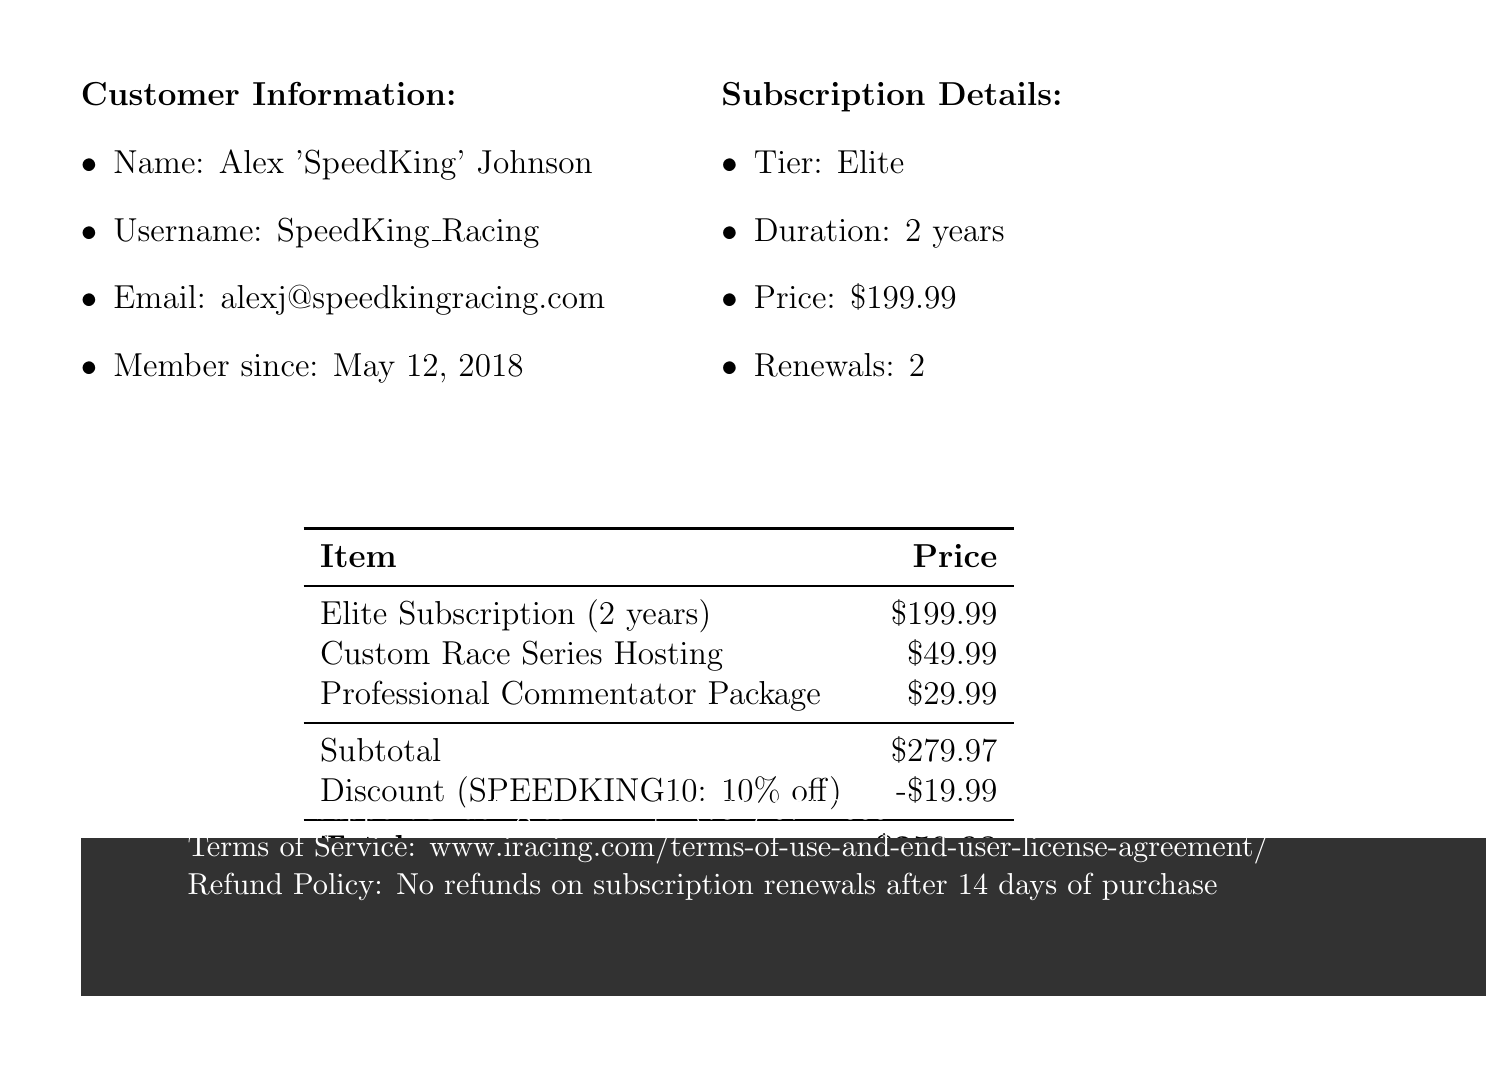What is the company name? The company name is mentioned at the top of the receipt.
Answer: iRacing.com Motorsport Simulations, LLC What is the price of the Elite subscription? The price for the Elite subscription is listed in the subscription details section of the document.
Answer: $199.99 Who is the current subscriber? The subscriber's name is included in the customer information section of the document.
Answer: Alex 'SpeedKing' Johnson How many renewals has the customer had? The number of renewals is detailed in the subscription history section.
Answer: 2 What discount code is mentioned in the document? The promotional offer section provides the discount code.
Answer: SPEEDKING10 What is the total amount after discount? The total amount is calculated in the summary table after applying the discount.
Answer: $259.98 What type of payment methods are accepted? The available payment methods are listed in a specific section of the document.
Answer: Credit Card, PayPal, Apple Pay, Google Pay What additional service costs $29.99? The additional services section provides the cost for each service.
Answer: Professional Commentator Package What is the refund policy on subscription renewals? The refund policy is stated in the legal information section of the document.
Answer: No refunds on subscription renewals after 14 days of purchase 